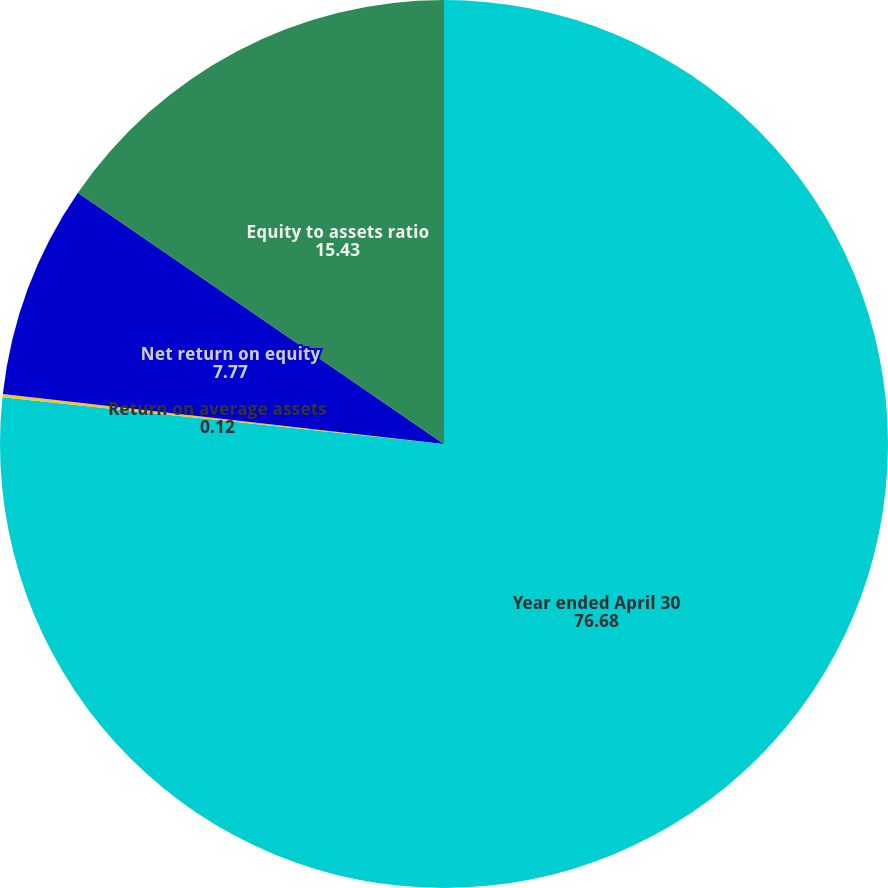Convert chart to OTSL. <chart><loc_0><loc_0><loc_500><loc_500><pie_chart><fcel>Year ended April 30<fcel>Return on average assets<fcel>Net return on equity<fcel>Equity to assets ratio<nl><fcel>76.68%<fcel>0.12%<fcel>7.77%<fcel>15.43%<nl></chart> 